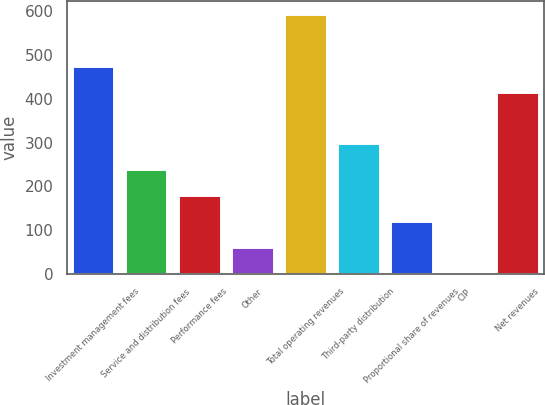Convert chart. <chart><loc_0><loc_0><loc_500><loc_500><bar_chart><fcel>Investment management fees<fcel>Service and distribution fees<fcel>Performance fees<fcel>Other<fcel>Total operating revenues<fcel>Third-party distribution<fcel>Proportional share of revenues<fcel>CIP<fcel>Net revenues<nl><fcel>475.11<fcel>239.54<fcel>180.43<fcel>62.21<fcel>594.2<fcel>298.65<fcel>121.32<fcel>3.1<fcel>416<nl></chart> 